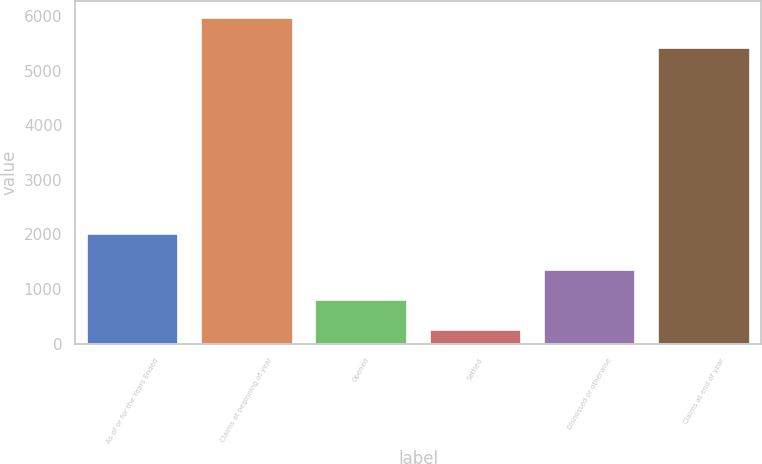Convert chart to OTSL. <chart><loc_0><loc_0><loc_500><loc_500><bar_chart><fcel>As of or for the Years Ended<fcel>Claims at beginning of year<fcel>Opened<fcel>Settled<fcel>Dismissed or otherwise<fcel>Claims at end of year<nl><fcel>2009<fcel>5970.7<fcel>796.7<fcel>243<fcel>1350.4<fcel>5417<nl></chart> 